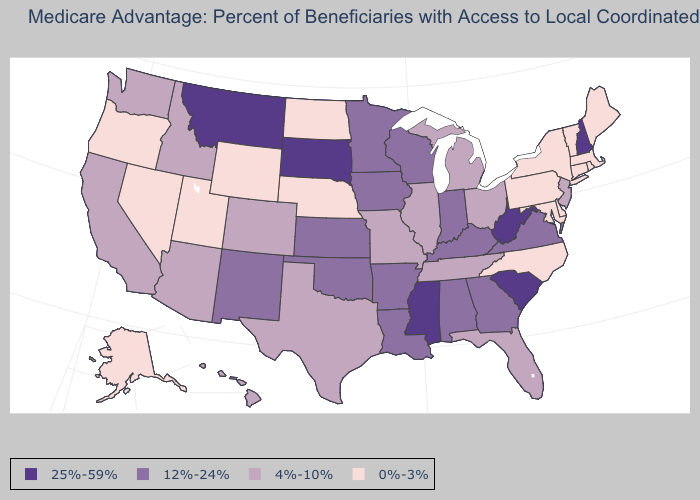Does Wisconsin have the highest value in the USA?
Be succinct. No. Name the states that have a value in the range 0%-3%?
Give a very brief answer. Alaska, Connecticut, Delaware, Massachusetts, Maryland, Maine, North Carolina, North Dakota, Nebraska, Nevada, New York, Oregon, Pennsylvania, Rhode Island, Utah, Vermont, Wyoming. What is the highest value in the USA?
Answer briefly. 25%-59%. Among the states that border Maryland , which have the highest value?
Be succinct. West Virginia. Does the first symbol in the legend represent the smallest category?
Quick response, please. No. Name the states that have a value in the range 4%-10%?
Concise answer only. Arizona, California, Colorado, Florida, Hawaii, Idaho, Illinois, Michigan, Missouri, New Jersey, Ohio, Tennessee, Texas, Washington. How many symbols are there in the legend?
Quick response, please. 4. Name the states that have a value in the range 4%-10%?
Concise answer only. Arizona, California, Colorado, Florida, Hawaii, Idaho, Illinois, Michigan, Missouri, New Jersey, Ohio, Tennessee, Texas, Washington. What is the highest value in the USA?
Give a very brief answer. 25%-59%. Name the states that have a value in the range 4%-10%?
Concise answer only. Arizona, California, Colorado, Florida, Hawaii, Idaho, Illinois, Michigan, Missouri, New Jersey, Ohio, Tennessee, Texas, Washington. Name the states that have a value in the range 12%-24%?
Answer briefly. Alabama, Arkansas, Georgia, Iowa, Indiana, Kansas, Kentucky, Louisiana, Minnesota, New Mexico, Oklahoma, Virginia, Wisconsin. What is the value of Florida?
Short answer required. 4%-10%. Among the states that border Nebraska , which have the lowest value?
Keep it brief. Wyoming. What is the lowest value in states that border Mississippi?
Give a very brief answer. 4%-10%. Which states have the lowest value in the MidWest?
Short answer required. North Dakota, Nebraska. 